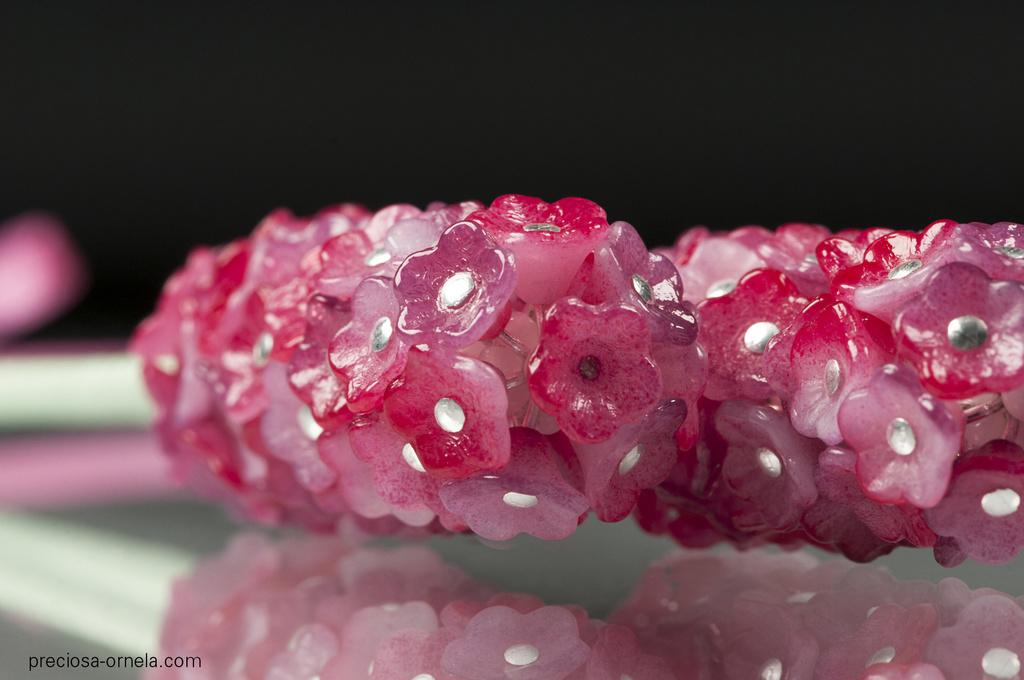What is on the table in the image? There are flowers on a table in the image. What type of plant can be seen growing on the seashore in the image? There is no seashore or plant visible in the image; it only features flowers on a table. 